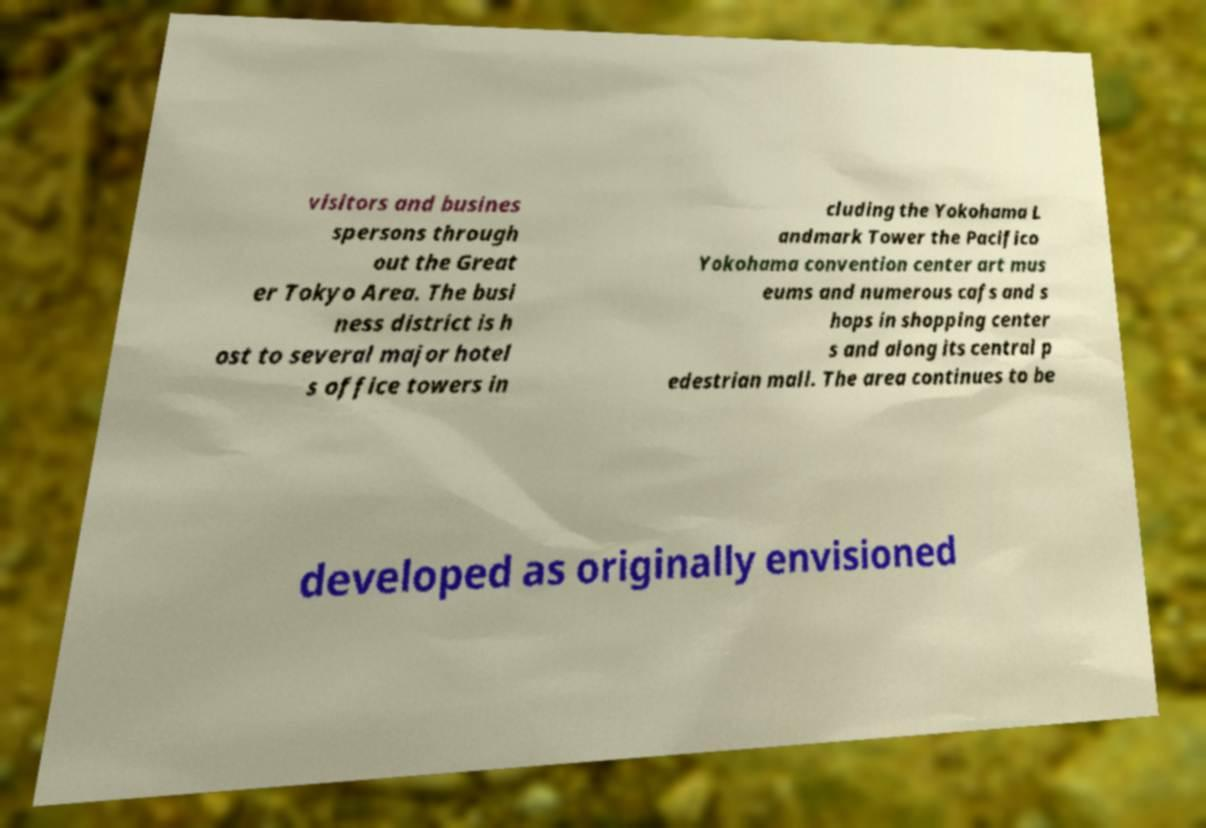Can you read and provide the text displayed in the image?This photo seems to have some interesting text. Can you extract and type it out for me? visitors and busines spersons through out the Great er Tokyo Area. The busi ness district is h ost to several major hotel s office towers in cluding the Yokohama L andmark Tower the Pacifico Yokohama convention center art mus eums and numerous cafs and s hops in shopping center s and along its central p edestrian mall. The area continues to be developed as originally envisioned 